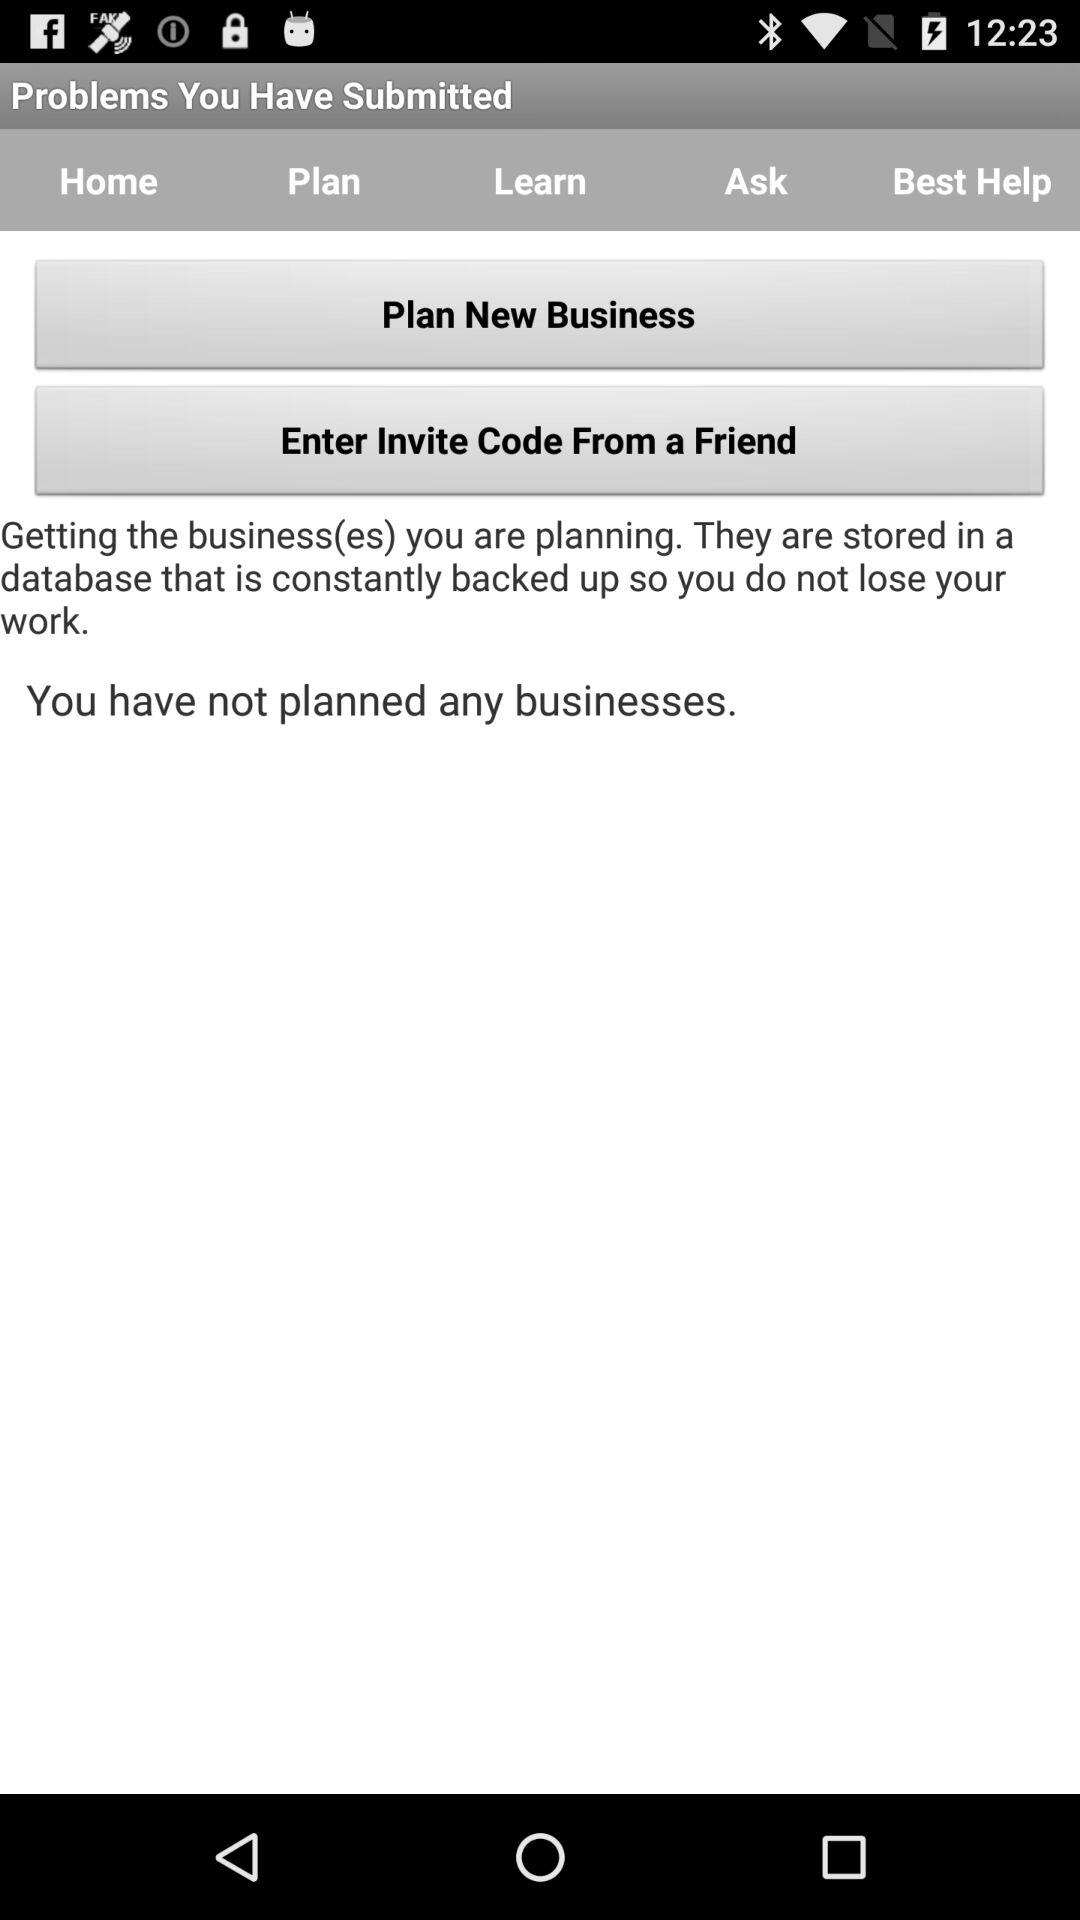How many businesses have I planned?
Answer the question using a single word or phrase. 0 